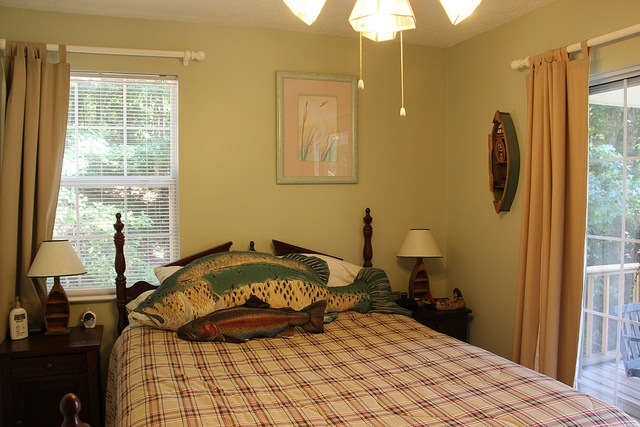Describe the objects in this image and their specific colors. I can see bed in olive, tan, and black tones, boat in olive, black, and maroon tones, boat in olive, black, maroon, and brown tones, and bottle in olive, black, and maroon tones in this image. 